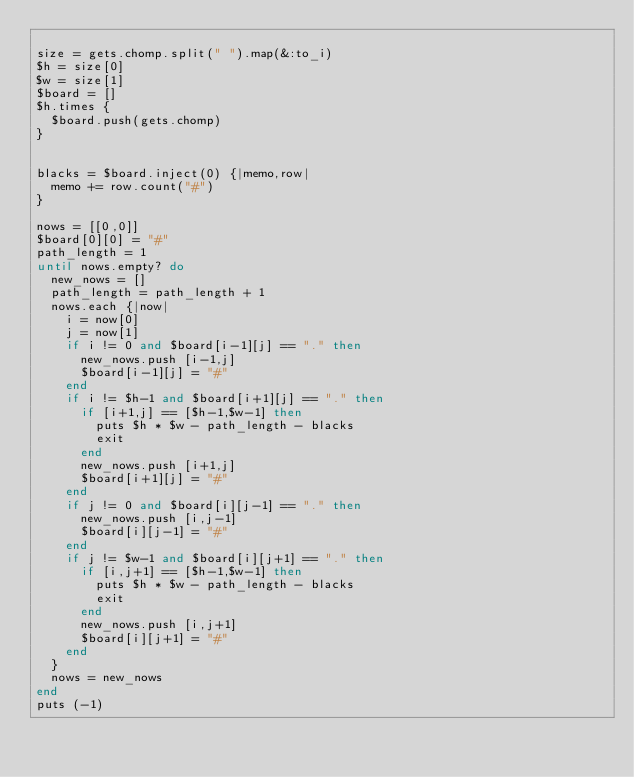Convert code to text. <code><loc_0><loc_0><loc_500><loc_500><_Ruby_>
size = gets.chomp.split(" ").map(&:to_i)
$h = size[0]
$w = size[1]
$board = []
$h.times {
  $board.push(gets.chomp)
}


blacks = $board.inject(0) {|memo,row|
  memo += row.count("#")
}

nows = [[0,0]]
$board[0][0] = "#"
path_length = 1
until nows.empty? do
  new_nows = []
  path_length = path_length + 1
  nows.each {|now|
    i = now[0]
    j = now[1]
    if i != 0 and $board[i-1][j] == "." then
      new_nows.push [i-1,j]
      $board[i-1][j] = "#"
    end
    if i != $h-1 and $board[i+1][j] == "." then
      if [i+1,j] == [$h-1,$w-1] then
        puts $h * $w - path_length - blacks
        exit
      end
      new_nows.push [i+1,j]
      $board[i+1][j] = "#"
    end
    if j != 0 and $board[i][j-1] == "." then
      new_nows.push [i,j-1]
      $board[i][j-1] = "#"
    end
    if j != $w-1 and $board[i][j+1] == "." then
      if [i,j+1] == [$h-1,$w-1] then
        puts $h * $w - path_length - blacks
        exit
      end
      new_nows.push [i,j+1]
      $board[i][j+1] = "#"
    end
  }
  nows = new_nows
end
puts (-1)
</code> 